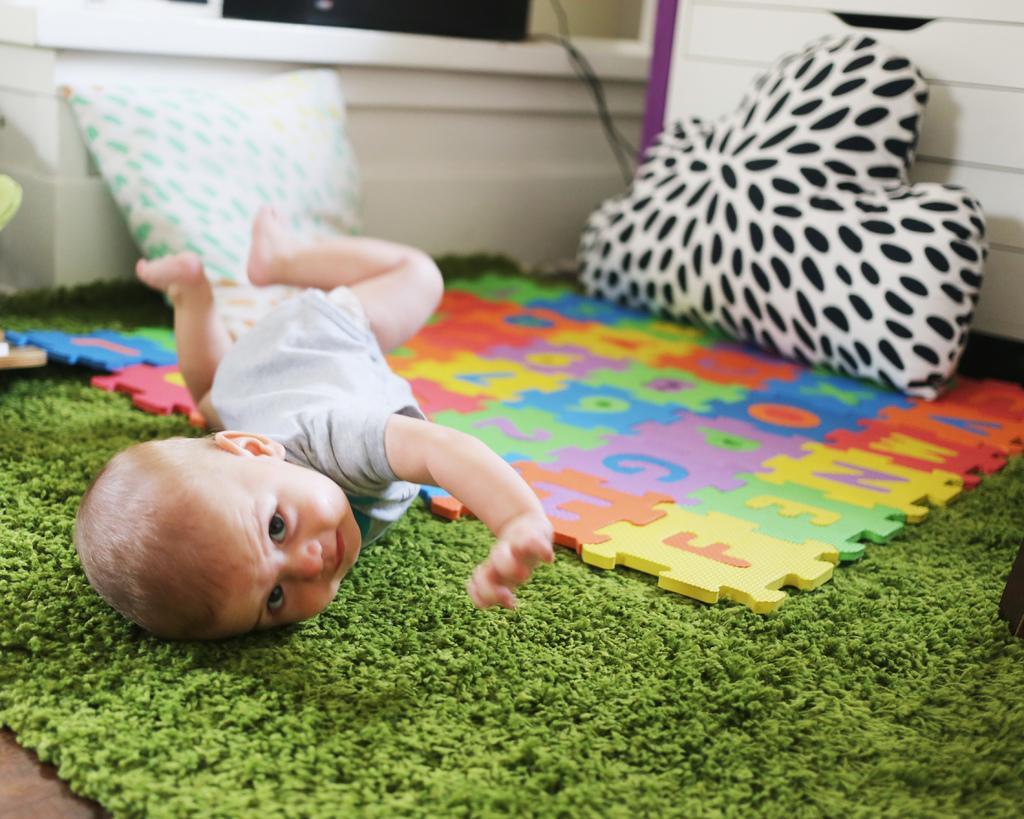Could you give a brief overview of what you see in this image? In this image there is a floor mat at the bottom. It looks like a pillow on the right corner. We can see a kid, pillow, toys, wall. 